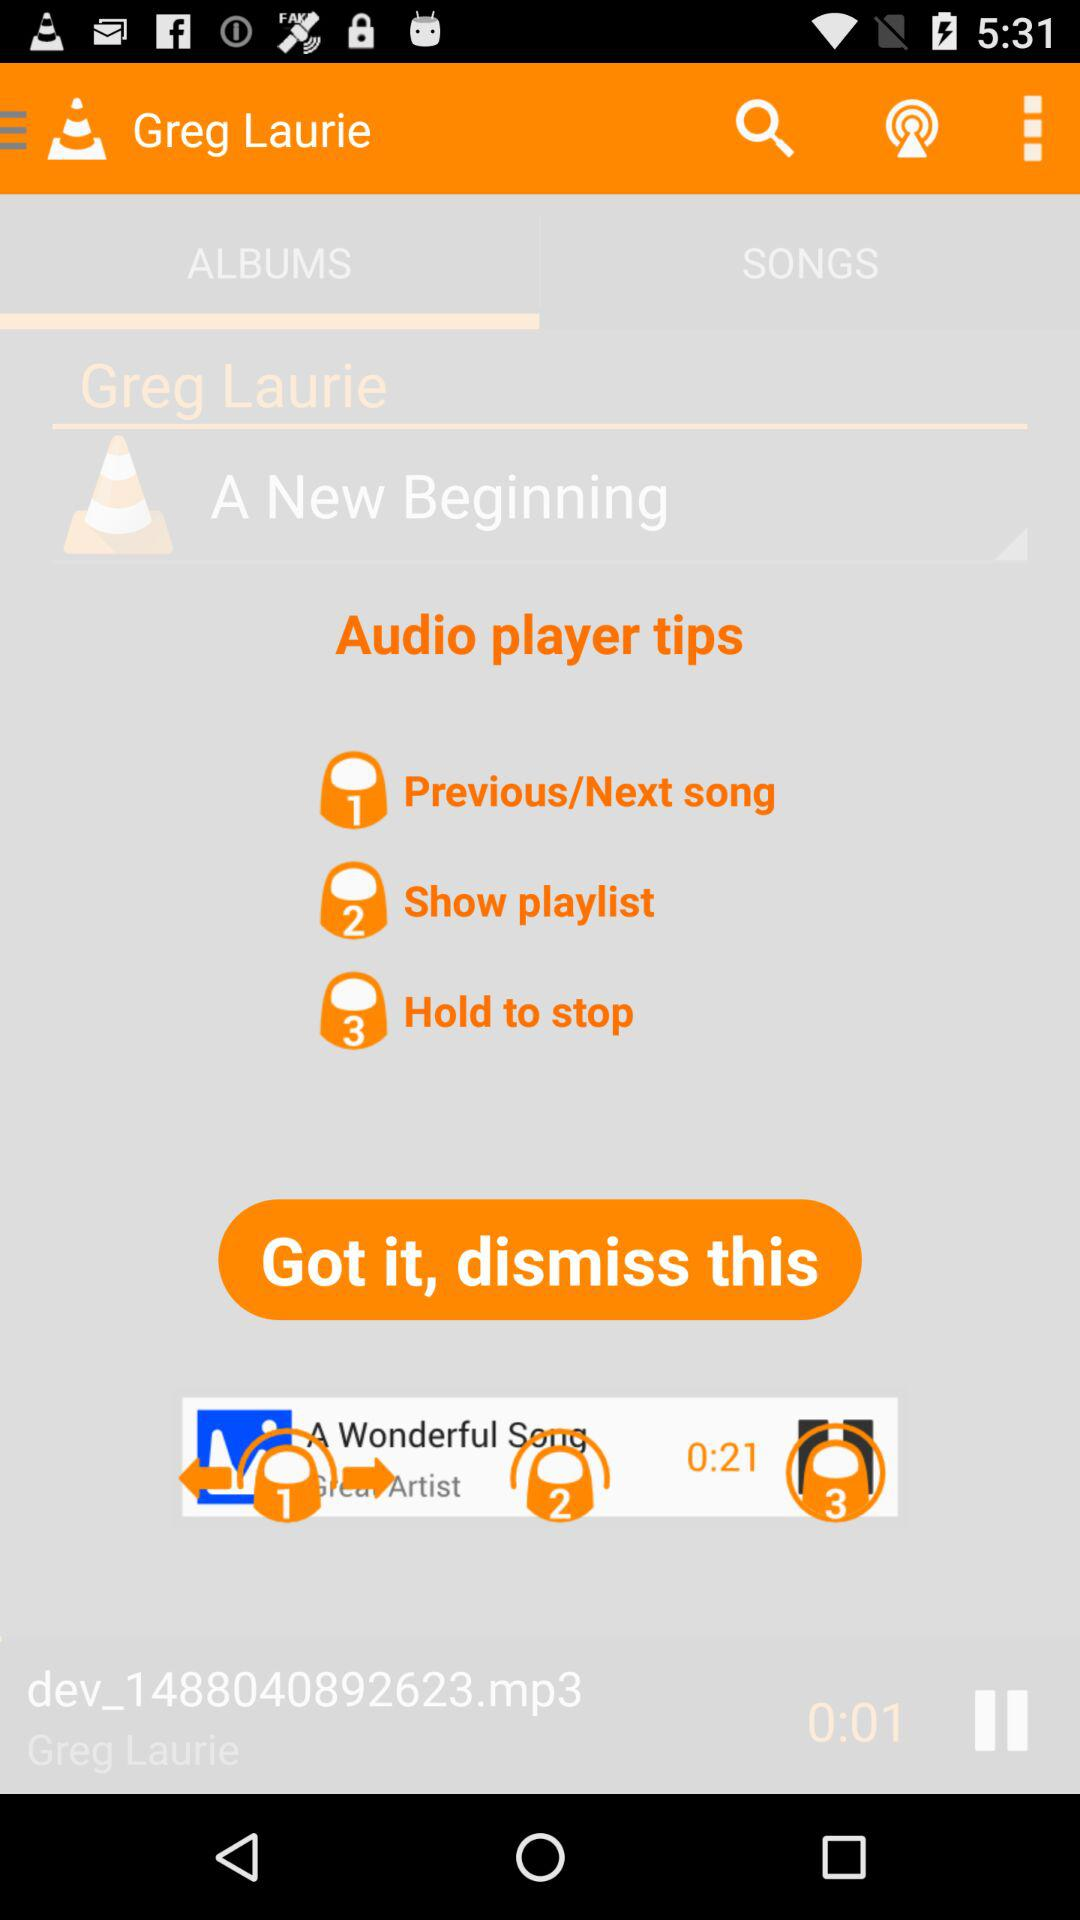Which song is currently playing? The song is dev_1488040892623.mp3. 